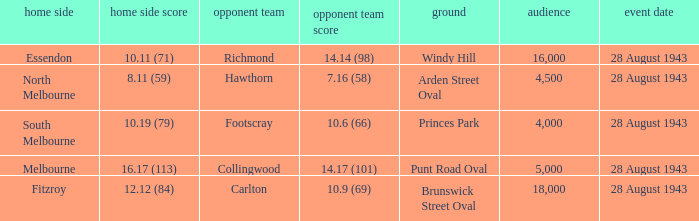Would you be able to parse every entry in this table? {'header': ['home side', 'home side score', 'opponent team', 'opponent team score', 'ground', 'audience', 'event date'], 'rows': [['Essendon', '10.11 (71)', 'Richmond', '14.14 (98)', 'Windy Hill', '16,000', '28 August 1943'], ['North Melbourne', '8.11 (59)', 'Hawthorn', '7.16 (58)', 'Arden Street Oval', '4,500', '28 August 1943'], ['South Melbourne', '10.19 (79)', 'Footscray', '10.6 (66)', 'Princes Park', '4,000', '28 August 1943'], ['Melbourne', '16.17 (113)', 'Collingwood', '14.17 (101)', 'Punt Road Oval', '5,000', '28 August 1943'], ['Fitzroy', '12.12 (84)', 'Carlton', '10.9 (69)', 'Brunswick Street Oval', '18,000', '28 August 1943']]} What game showed a home team score of 8.11 (59)? 28 August 1943. 